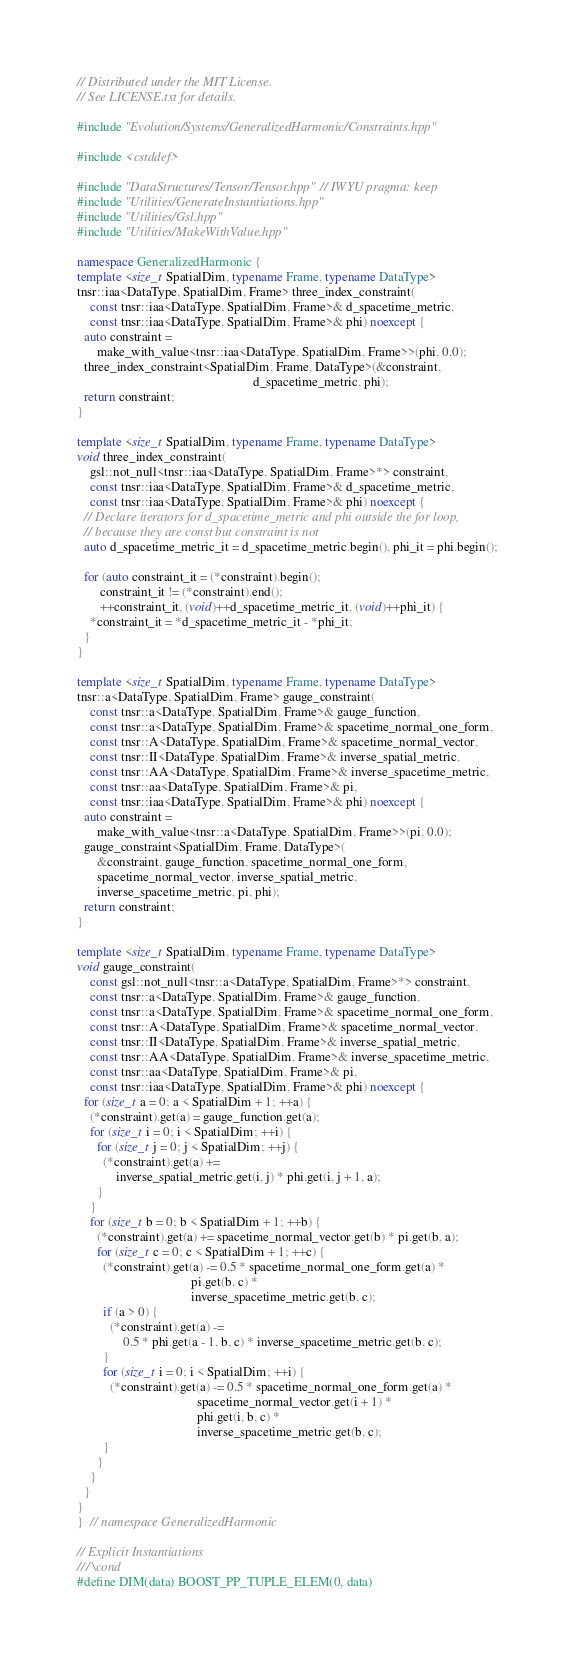Convert code to text. <code><loc_0><loc_0><loc_500><loc_500><_C++_>// Distributed under the MIT License.
// See LICENSE.txt for details.

#include "Evolution/Systems/GeneralizedHarmonic/Constraints.hpp"

#include <cstddef>

#include "DataStructures/Tensor/Tensor.hpp"  // IWYU pragma: keep
#include "Utilities/GenerateInstantiations.hpp"
#include "Utilities/Gsl.hpp"
#include "Utilities/MakeWithValue.hpp"

namespace GeneralizedHarmonic {
template <size_t SpatialDim, typename Frame, typename DataType>
tnsr::iaa<DataType, SpatialDim, Frame> three_index_constraint(
    const tnsr::iaa<DataType, SpatialDim, Frame>& d_spacetime_metric,
    const tnsr::iaa<DataType, SpatialDim, Frame>& phi) noexcept {
  auto constraint =
      make_with_value<tnsr::iaa<DataType, SpatialDim, Frame>>(phi, 0.0);
  three_index_constraint<SpatialDim, Frame, DataType>(&constraint,
                                                      d_spacetime_metric, phi);
  return constraint;
}

template <size_t SpatialDim, typename Frame, typename DataType>
void three_index_constraint(
    gsl::not_null<tnsr::iaa<DataType, SpatialDim, Frame>*> constraint,
    const tnsr::iaa<DataType, SpatialDim, Frame>& d_spacetime_metric,
    const tnsr::iaa<DataType, SpatialDim, Frame>& phi) noexcept {
  // Declare iterators for d_spacetime_metric and phi outside the for loop,
  // because they are const but constraint is not
  auto d_spacetime_metric_it = d_spacetime_metric.begin(), phi_it = phi.begin();

  for (auto constraint_it = (*constraint).begin();
       constraint_it != (*constraint).end();
       ++constraint_it, (void)++d_spacetime_metric_it, (void)++phi_it) {
    *constraint_it = *d_spacetime_metric_it - *phi_it;
  }
}

template <size_t SpatialDim, typename Frame, typename DataType>
tnsr::a<DataType, SpatialDim, Frame> gauge_constraint(
    const tnsr::a<DataType, SpatialDim, Frame>& gauge_function,
    const tnsr::a<DataType, SpatialDim, Frame>& spacetime_normal_one_form,
    const tnsr::A<DataType, SpatialDim, Frame>& spacetime_normal_vector,
    const tnsr::II<DataType, SpatialDim, Frame>& inverse_spatial_metric,
    const tnsr::AA<DataType, SpatialDim, Frame>& inverse_spacetime_metric,
    const tnsr::aa<DataType, SpatialDim, Frame>& pi,
    const tnsr::iaa<DataType, SpatialDim, Frame>& phi) noexcept {
  auto constraint =
      make_with_value<tnsr::a<DataType, SpatialDim, Frame>>(pi, 0.0);
  gauge_constraint<SpatialDim, Frame, DataType>(
      &constraint, gauge_function, spacetime_normal_one_form,
      spacetime_normal_vector, inverse_spatial_metric,
      inverse_spacetime_metric, pi, phi);
  return constraint;
}

template <size_t SpatialDim, typename Frame, typename DataType>
void gauge_constraint(
    const gsl::not_null<tnsr::a<DataType, SpatialDim, Frame>*> constraint,
    const tnsr::a<DataType, SpatialDim, Frame>& gauge_function,
    const tnsr::a<DataType, SpatialDim, Frame>& spacetime_normal_one_form,
    const tnsr::A<DataType, SpatialDim, Frame>& spacetime_normal_vector,
    const tnsr::II<DataType, SpatialDim, Frame>& inverse_spatial_metric,
    const tnsr::AA<DataType, SpatialDim, Frame>& inverse_spacetime_metric,
    const tnsr::aa<DataType, SpatialDim, Frame>& pi,
    const tnsr::iaa<DataType, SpatialDim, Frame>& phi) noexcept {
  for (size_t a = 0; a < SpatialDim + 1; ++a) {
    (*constraint).get(a) = gauge_function.get(a);
    for (size_t i = 0; i < SpatialDim; ++i) {
      for (size_t j = 0; j < SpatialDim; ++j) {
        (*constraint).get(a) +=
            inverse_spatial_metric.get(i, j) * phi.get(i, j + 1, a);
      }
    }
    for (size_t b = 0; b < SpatialDim + 1; ++b) {
      (*constraint).get(a) += spacetime_normal_vector.get(b) * pi.get(b, a);
      for (size_t c = 0; c < SpatialDim + 1; ++c) {
        (*constraint).get(a) -= 0.5 * spacetime_normal_one_form.get(a) *
                                   pi.get(b, c) *
                                   inverse_spacetime_metric.get(b, c);
        if (a > 0) {
          (*constraint).get(a) -=
              0.5 * phi.get(a - 1, b, c) * inverse_spacetime_metric.get(b, c);
        }
        for (size_t i = 0; i < SpatialDim; ++i) {
          (*constraint).get(a) -= 0.5 * spacetime_normal_one_form.get(a) *
                                     spacetime_normal_vector.get(i + 1) *
                                     phi.get(i, b, c) *
                                     inverse_spacetime_metric.get(b, c);
        }
      }
    }
  }
}
}  // namespace GeneralizedHarmonic

// Explicit Instantiations
/// \cond
#define DIM(data) BOOST_PP_TUPLE_ELEM(0, data)</code> 